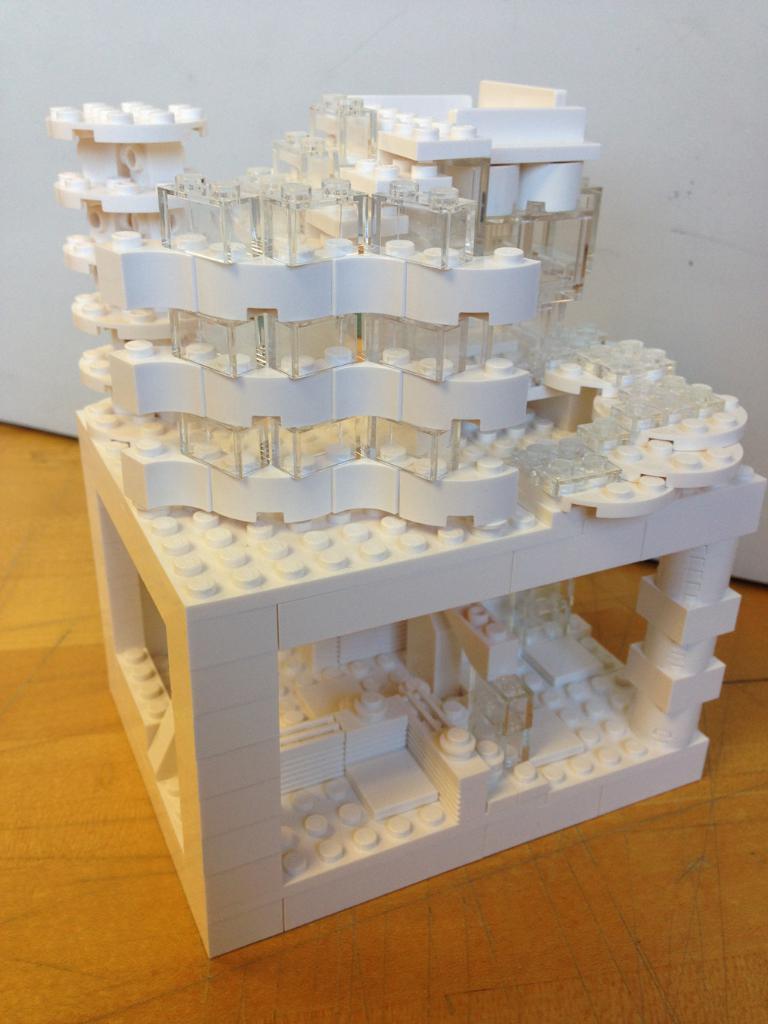Please provide a concise description of this image. In this image we can see a miniature building on a platform. There is a white background. 